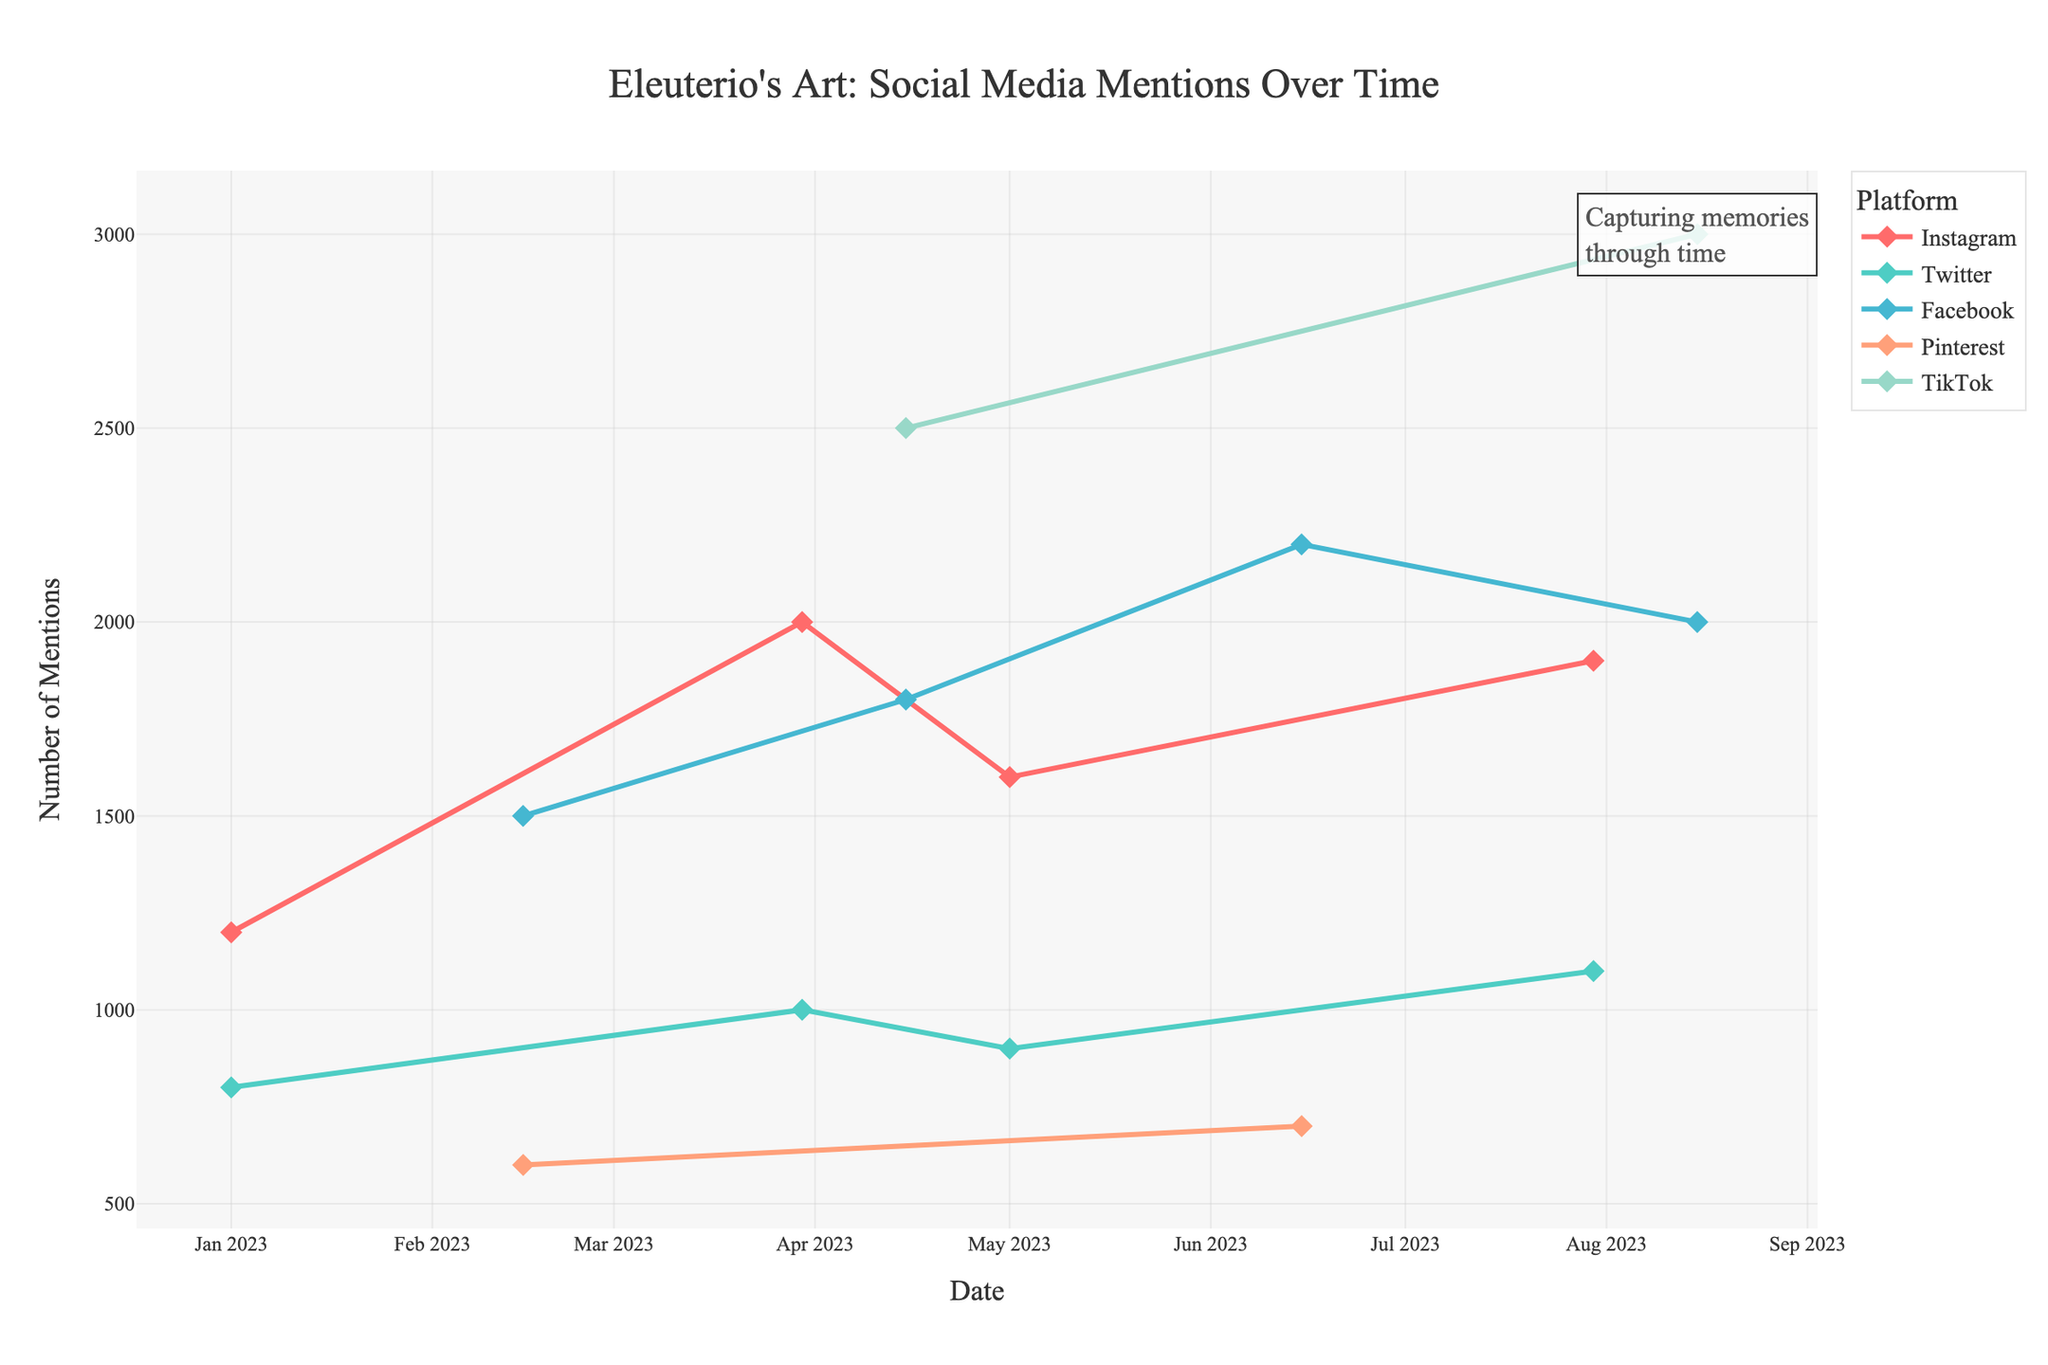What is the total number of mentions across all platforms on February 15? On February 15, we have mentions for Facebook (#EleuterioStories: 1500) and Pinterest (#EleuterioInspiration: 600). Summing these gives 1500 + 600 = 2100.
Answer: 2100 Which platform had the highest number of mentions on April 15, and what was the number? On April 15, Facebook had 1800 mentions for #EleuterioMemories, and TikTok had 2500 mentions for #EleuterioChallenge. TikTok had the highest number with 2500 mentions.
Answer: TikTok (2500) Between Instagram and Twitter, which platform consistently shows a higher number of mentions for each respective period in the data provided? Comparing the mentions for each date:
- 2023-01-01: Instagram (1200) vs Twitter (800) => Instagram
- 2023-03-30: Instagram (2000) vs Twitter (1000) => Instagram
- 2023-05-01: Instagram (1600) vs Twitter (900) => Instagram
- 2023-07-30: Instagram (1900) vs Twitter (1100) => Instagram
Instagram shows higher mentions in each observed period.
Answer: Instagram How did the number of mentions on TikTok change from April 15 to August 15? On April 15, TikTok had 2500 mentions for #EleuterioChallenge. On August 15, TikTok had 3000 mentions for #EleuterioInspired. The change is 3000 - 2500 = 500 mentions.
Answer: Increased by 500 What is the average positive sentiment percentage across all platforms on March 30? On March 30, Instagram (#EleuterioExhibit) had 80% positive sentiment, and Twitter (#EleuterioLegacy) had 65% positive sentiment. The average is (80 + 65) / 2 = 72.5%.
Answer: 72.5% Which platform had the lowest number of mentions on June 15, and what was the number? On June 15, Facebook (#EleuterioRetrospective) had 2200 mentions, and Pinterest (#EleuterioMoodboard) had 700 mentions. Pinterest had the lowest with 700 mentions.
Answer: Pinterest (700) What are the visual attributes of the line representing Instagram mentions? The line for Instagram mentions is marked with diamonds and has a color consistent across the chart. It also shows a generally upward trend with peaks on specific dates.
Answer: Diamonds, upward trend, consistent color Which day had the highest overall number of mentions, and which platform contributed the most to it? The highest overall number of mentions is on August 15 with:
- Facebook (#EleuterioHeritage): 2000
- TikTok (#EleuterioInspired): 3000
The platform contributing the most is TikTok with 3000 mentions.
Answer: August 15, TikTok If we combine the mentions from January 1 and February 15, which platform amasses the highest total, and what is the total? Summing the mentions for each platform on January 1 and February 15:
- Instagram: 1200
- Twitter: 800
- Facebook: 1500
- Pinterest: 600
Facebook has the highest total with 1500 mentions.
Answer: Facebook (1500) 